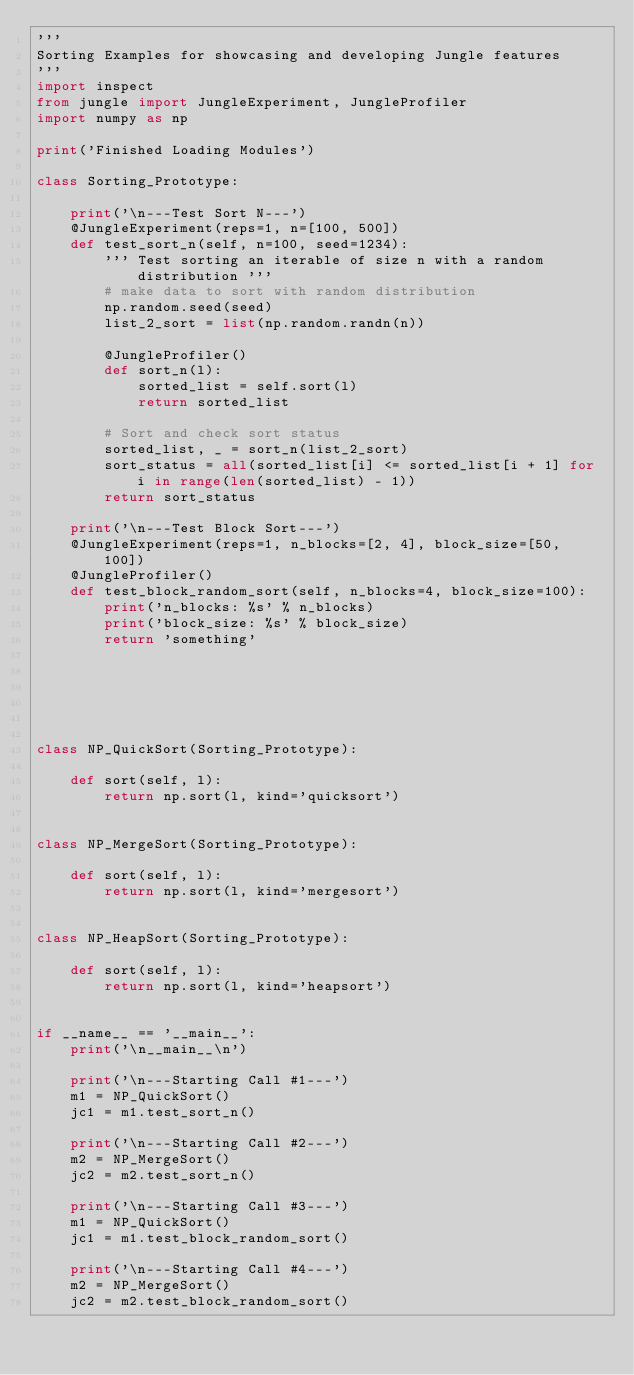Convert code to text. <code><loc_0><loc_0><loc_500><loc_500><_Python_>'''
Sorting Examples for showcasing and developing Jungle features
'''
import inspect
from jungle import JungleExperiment, JungleProfiler
import numpy as np

print('Finished Loading Modules')

class Sorting_Prototype:

    print('\n---Test Sort N---')
    @JungleExperiment(reps=1, n=[100, 500])
    def test_sort_n(self, n=100, seed=1234):
        ''' Test sorting an iterable of size n with a random distribution '''
        # make data to sort with random distribution
        np.random.seed(seed)
        list_2_sort = list(np.random.randn(n))

        @JungleProfiler()
        def sort_n(l):
            sorted_list = self.sort(l)
            return sorted_list

        # Sort and check sort status
        sorted_list, _ = sort_n(list_2_sort)
        sort_status = all(sorted_list[i] <= sorted_list[i + 1] for i in range(len(sorted_list) - 1))
        return sort_status

    print('\n---Test Block Sort---')
    @JungleExperiment(reps=1, n_blocks=[2, 4], block_size=[50, 100])
    @JungleProfiler()
    def test_block_random_sort(self, n_blocks=4, block_size=100):
        print('n_blocks: %s' % n_blocks)
        print('block_size: %s' % block_size)
        return 'something'






class NP_QuickSort(Sorting_Prototype):

    def sort(self, l):
        return np.sort(l, kind='quicksort')


class NP_MergeSort(Sorting_Prototype):

    def sort(self, l):
        return np.sort(l, kind='mergesort')


class NP_HeapSort(Sorting_Prototype):

    def sort(self, l):
        return np.sort(l, kind='heapsort')


if __name__ == '__main__':
    print('\n__main__\n')

    print('\n---Starting Call #1---')
    m1 = NP_QuickSort()
    jc1 = m1.test_sort_n()

    print('\n---Starting Call #2---')
    m2 = NP_MergeSort()
    jc2 = m2.test_sort_n()

    print('\n---Starting Call #3---')
    m1 = NP_QuickSort()
    jc1 = m1.test_block_random_sort()

    print('\n---Starting Call #4---')
    m2 = NP_MergeSort()
    jc2 = m2.test_block_random_sort()
</code> 